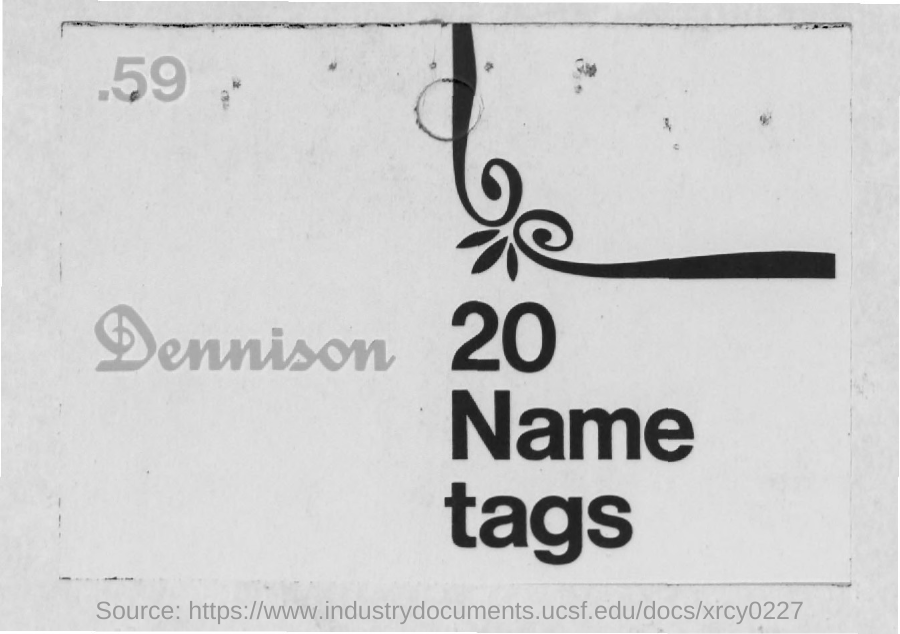What is  the number given at the left top corner of the page?
Provide a short and direct response. 59. How many "Name tags" are mentioned?
Your response must be concise. 20. What is written to the left side of "20 Name tags"?
Provide a succinct answer. Dennison. 